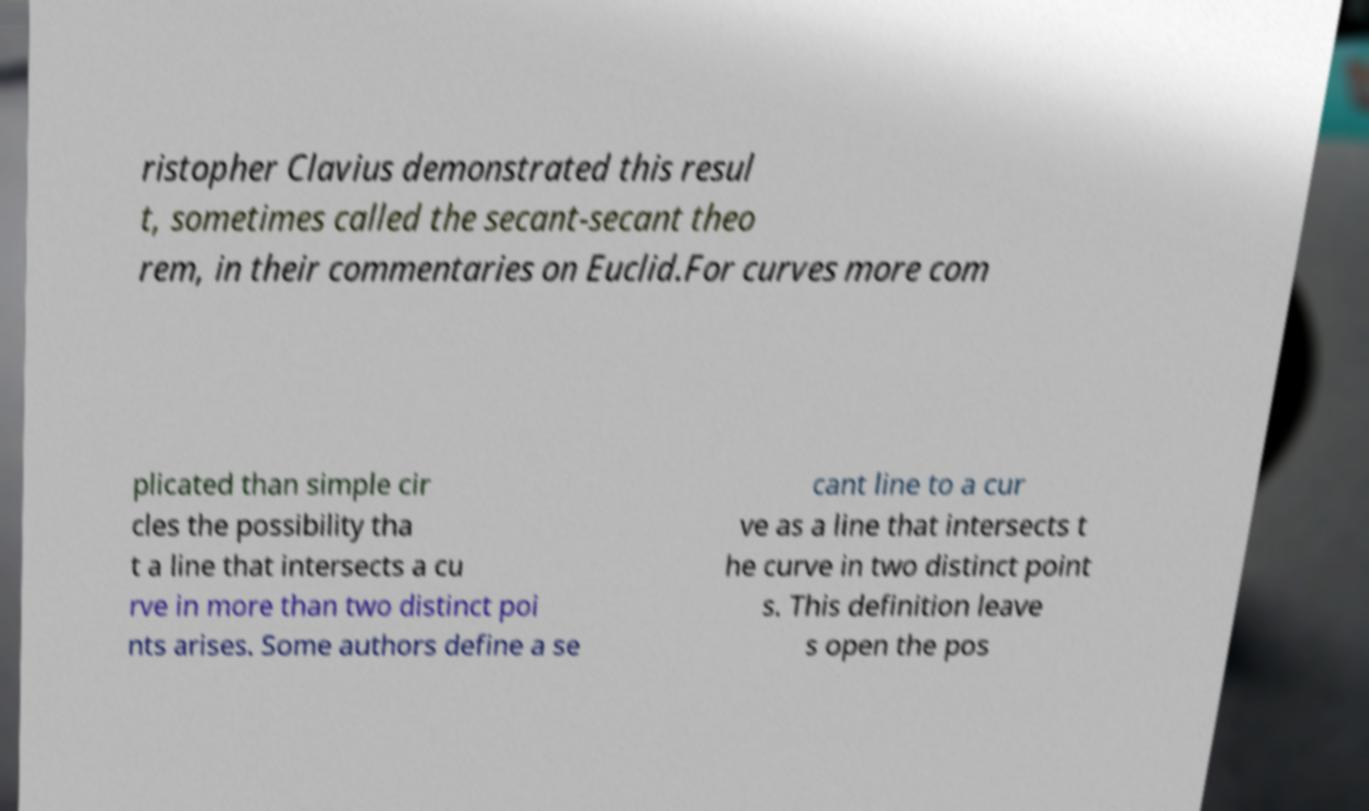Please read and relay the text visible in this image. What does it say? ristopher Clavius demonstrated this resul t, sometimes called the secant-secant theo rem, in their commentaries on Euclid.For curves more com plicated than simple cir cles the possibility tha t a line that intersects a cu rve in more than two distinct poi nts arises. Some authors define a se cant line to a cur ve as a line that intersects t he curve in two distinct point s. This definition leave s open the pos 